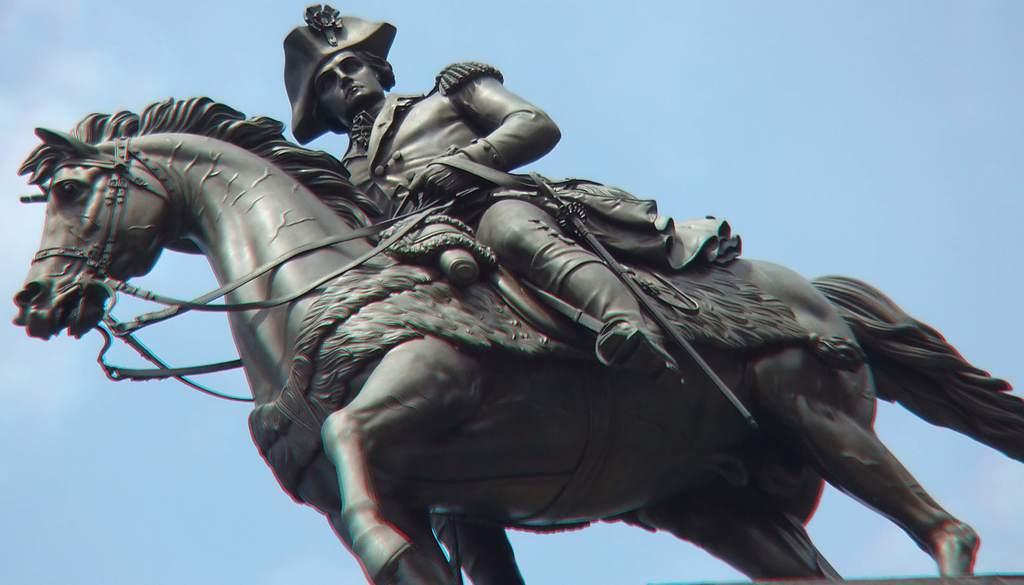How would you summarize this image in a sentence or two? In the center of the image we can see statue. In the background there is sky. 